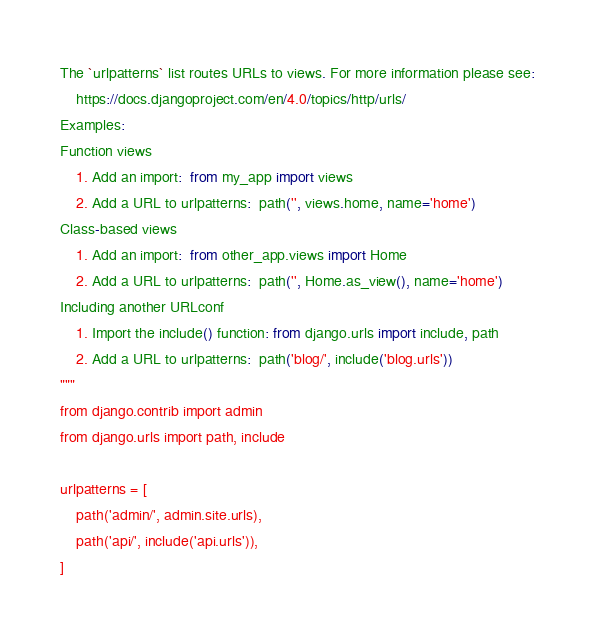<code> <loc_0><loc_0><loc_500><loc_500><_Python_>
The `urlpatterns` list routes URLs to views. For more information please see:
    https://docs.djangoproject.com/en/4.0/topics/http/urls/
Examples:
Function views
    1. Add an import:  from my_app import views
    2. Add a URL to urlpatterns:  path('', views.home, name='home')
Class-based views
    1. Add an import:  from other_app.views import Home
    2. Add a URL to urlpatterns:  path('', Home.as_view(), name='home')
Including another URLconf
    1. Import the include() function: from django.urls import include, path
    2. Add a URL to urlpatterns:  path('blog/', include('blog.urls'))
"""
from django.contrib import admin
from django.urls import path, include

urlpatterns = [
    path('admin/', admin.site.urls),
    path('api/', include('api.urls')),
]
</code> 